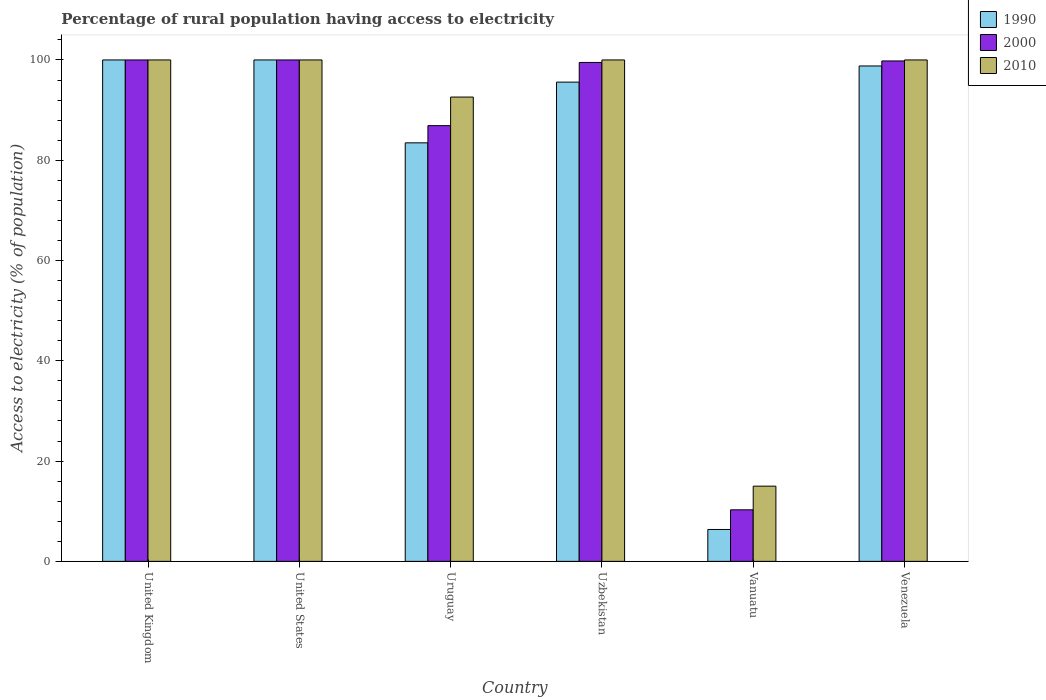How many groups of bars are there?
Ensure brevity in your answer.  6. Are the number of bars on each tick of the X-axis equal?
Offer a terse response. Yes. How many bars are there on the 2nd tick from the left?
Offer a very short reply. 3. What is the label of the 4th group of bars from the left?
Your response must be concise. Uzbekistan. What is the percentage of rural population having access to electricity in 1990 in Vanuatu?
Offer a very short reply. 6.36. Across all countries, what is the minimum percentage of rural population having access to electricity in 2000?
Make the answer very short. 10.28. In which country was the percentage of rural population having access to electricity in 2010 maximum?
Ensure brevity in your answer.  United Kingdom. In which country was the percentage of rural population having access to electricity in 1990 minimum?
Provide a succinct answer. Vanuatu. What is the total percentage of rural population having access to electricity in 2010 in the graph?
Your response must be concise. 507.6. What is the difference between the percentage of rural population having access to electricity in 2000 in Uruguay and that in Uzbekistan?
Keep it short and to the point. -12.6. What is the difference between the percentage of rural population having access to electricity in 1990 in Vanuatu and the percentage of rural population having access to electricity in 2000 in United Kingdom?
Your answer should be very brief. -93.64. What is the average percentage of rural population having access to electricity in 1990 per country?
Offer a very short reply. 80.7. What is the difference between the percentage of rural population having access to electricity of/in 2000 and percentage of rural population having access to electricity of/in 2010 in Venezuela?
Your response must be concise. -0.2. What is the ratio of the percentage of rural population having access to electricity in 2000 in United Kingdom to that in Uzbekistan?
Keep it short and to the point. 1.01. What is the difference between the highest and the second highest percentage of rural population having access to electricity in 2000?
Offer a terse response. -0.2. What is the difference between the highest and the lowest percentage of rural population having access to electricity in 1990?
Provide a short and direct response. 93.64. In how many countries, is the percentage of rural population having access to electricity in 2000 greater than the average percentage of rural population having access to electricity in 2000 taken over all countries?
Give a very brief answer. 5. What does the 3rd bar from the right in Venezuela represents?
Your answer should be very brief. 1990. Is it the case that in every country, the sum of the percentage of rural population having access to electricity in 2000 and percentage of rural population having access to electricity in 2010 is greater than the percentage of rural population having access to electricity in 1990?
Offer a very short reply. Yes. Are all the bars in the graph horizontal?
Ensure brevity in your answer.  No. What is the difference between two consecutive major ticks on the Y-axis?
Your answer should be compact. 20. Are the values on the major ticks of Y-axis written in scientific E-notation?
Provide a succinct answer. No. Does the graph contain any zero values?
Provide a short and direct response. No. How many legend labels are there?
Provide a short and direct response. 3. How are the legend labels stacked?
Offer a terse response. Vertical. What is the title of the graph?
Your answer should be compact. Percentage of rural population having access to electricity. Does "1963" appear as one of the legend labels in the graph?
Keep it short and to the point. No. What is the label or title of the X-axis?
Your answer should be compact. Country. What is the label or title of the Y-axis?
Offer a terse response. Access to electricity (% of population). What is the Access to electricity (% of population) of 1990 in United Kingdom?
Your answer should be compact. 100. What is the Access to electricity (% of population) of 2000 in United Kingdom?
Offer a very short reply. 100. What is the Access to electricity (% of population) in 2010 in United States?
Give a very brief answer. 100. What is the Access to electricity (% of population) in 1990 in Uruguay?
Your answer should be compact. 83.47. What is the Access to electricity (% of population) of 2000 in Uruguay?
Your answer should be compact. 86.9. What is the Access to electricity (% of population) in 2010 in Uruguay?
Give a very brief answer. 92.6. What is the Access to electricity (% of population) in 1990 in Uzbekistan?
Ensure brevity in your answer.  95.58. What is the Access to electricity (% of population) in 2000 in Uzbekistan?
Your answer should be compact. 99.5. What is the Access to electricity (% of population) in 2010 in Uzbekistan?
Make the answer very short. 100. What is the Access to electricity (% of population) in 1990 in Vanuatu?
Provide a short and direct response. 6.36. What is the Access to electricity (% of population) in 2000 in Vanuatu?
Ensure brevity in your answer.  10.28. What is the Access to electricity (% of population) of 2010 in Vanuatu?
Offer a terse response. 15. What is the Access to electricity (% of population) of 1990 in Venezuela?
Give a very brief answer. 98.8. What is the Access to electricity (% of population) in 2000 in Venezuela?
Give a very brief answer. 99.8. What is the Access to electricity (% of population) of 2010 in Venezuela?
Ensure brevity in your answer.  100. Across all countries, what is the maximum Access to electricity (% of population) of 1990?
Ensure brevity in your answer.  100. Across all countries, what is the maximum Access to electricity (% of population) of 2000?
Your answer should be very brief. 100. Across all countries, what is the minimum Access to electricity (% of population) of 1990?
Ensure brevity in your answer.  6.36. Across all countries, what is the minimum Access to electricity (% of population) in 2000?
Give a very brief answer. 10.28. Across all countries, what is the minimum Access to electricity (% of population) of 2010?
Give a very brief answer. 15. What is the total Access to electricity (% of population) of 1990 in the graph?
Offer a terse response. 484.21. What is the total Access to electricity (% of population) of 2000 in the graph?
Provide a short and direct response. 496.48. What is the total Access to electricity (% of population) of 2010 in the graph?
Your answer should be very brief. 507.6. What is the difference between the Access to electricity (% of population) of 1990 in United Kingdom and that in United States?
Your answer should be compact. 0. What is the difference between the Access to electricity (% of population) in 2000 in United Kingdom and that in United States?
Provide a succinct answer. 0. What is the difference between the Access to electricity (% of population) in 2010 in United Kingdom and that in United States?
Offer a very short reply. 0. What is the difference between the Access to electricity (% of population) of 1990 in United Kingdom and that in Uruguay?
Make the answer very short. 16.53. What is the difference between the Access to electricity (% of population) in 1990 in United Kingdom and that in Uzbekistan?
Give a very brief answer. 4.42. What is the difference between the Access to electricity (% of population) in 2010 in United Kingdom and that in Uzbekistan?
Your response must be concise. 0. What is the difference between the Access to electricity (% of population) in 1990 in United Kingdom and that in Vanuatu?
Ensure brevity in your answer.  93.64. What is the difference between the Access to electricity (% of population) in 2000 in United Kingdom and that in Vanuatu?
Provide a short and direct response. 89.72. What is the difference between the Access to electricity (% of population) in 2010 in United Kingdom and that in Vanuatu?
Give a very brief answer. 85. What is the difference between the Access to electricity (% of population) of 1990 in United Kingdom and that in Venezuela?
Ensure brevity in your answer.  1.2. What is the difference between the Access to electricity (% of population) of 2010 in United Kingdom and that in Venezuela?
Offer a very short reply. 0. What is the difference between the Access to electricity (% of population) in 1990 in United States and that in Uruguay?
Offer a very short reply. 16.53. What is the difference between the Access to electricity (% of population) in 1990 in United States and that in Uzbekistan?
Offer a terse response. 4.42. What is the difference between the Access to electricity (% of population) of 2010 in United States and that in Uzbekistan?
Keep it short and to the point. 0. What is the difference between the Access to electricity (% of population) in 1990 in United States and that in Vanuatu?
Your answer should be compact. 93.64. What is the difference between the Access to electricity (% of population) of 2000 in United States and that in Vanuatu?
Your response must be concise. 89.72. What is the difference between the Access to electricity (% of population) in 1990 in United States and that in Venezuela?
Offer a terse response. 1.2. What is the difference between the Access to electricity (% of population) of 2010 in United States and that in Venezuela?
Offer a very short reply. 0. What is the difference between the Access to electricity (% of population) in 1990 in Uruguay and that in Uzbekistan?
Your response must be concise. -12.11. What is the difference between the Access to electricity (% of population) of 2010 in Uruguay and that in Uzbekistan?
Your answer should be very brief. -7.4. What is the difference between the Access to electricity (% of population) of 1990 in Uruguay and that in Vanuatu?
Give a very brief answer. 77.11. What is the difference between the Access to electricity (% of population) of 2000 in Uruguay and that in Vanuatu?
Give a very brief answer. 76.62. What is the difference between the Access to electricity (% of population) in 2010 in Uruguay and that in Vanuatu?
Keep it short and to the point. 77.6. What is the difference between the Access to electricity (% of population) of 1990 in Uruguay and that in Venezuela?
Offer a very short reply. -15.33. What is the difference between the Access to electricity (% of population) of 2000 in Uruguay and that in Venezuela?
Offer a terse response. -12.9. What is the difference between the Access to electricity (% of population) of 1990 in Uzbekistan and that in Vanuatu?
Your answer should be very brief. 89.22. What is the difference between the Access to electricity (% of population) in 2000 in Uzbekistan and that in Vanuatu?
Keep it short and to the point. 89.22. What is the difference between the Access to electricity (% of population) in 2010 in Uzbekistan and that in Vanuatu?
Your answer should be compact. 85. What is the difference between the Access to electricity (% of population) in 1990 in Uzbekistan and that in Venezuela?
Ensure brevity in your answer.  -3.22. What is the difference between the Access to electricity (% of population) in 2010 in Uzbekistan and that in Venezuela?
Offer a terse response. 0. What is the difference between the Access to electricity (% of population) of 1990 in Vanuatu and that in Venezuela?
Your answer should be compact. -92.44. What is the difference between the Access to electricity (% of population) of 2000 in Vanuatu and that in Venezuela?
Offer a terse response. -89.52. What is the difference between the Access to electricity (% of population) in 2010 in Vanuatu and that in Venezuela?
Your response must be concise. -85. What is the difference between the Access to electricity (% of population) of 1990 in United Kingdom and the Access to electricity (% of population) of 2010 in Uruguay?
Provide a short and direct response. 7.4. What is the difference between the Access to electricity (% of population) of 2000 in United Kingdom and the Access to electricity (% of population) of 2010 in Uruguay?
Your response must be concise. 7.4. What is the difference between the Access to electricity (% of population) in 1990 in United Kingdom and the Access to electricity (% of population) in 2000 in Vanuatu?
Give a very brief answer. 89.72. What is the difference between the Access to electricity (% of population) of 1990 in United Kingdom and the Access to electricity (% of population) of 2010 in Vanuatu?
Your response must be concise. 85. What is the difference between the Access to electricity (% of population) of 2000 in United Kingdom and the Access to electricity (% of population) of 2010 in Vanuatu?
Provide a succinct answer. 85. What is the difference between the Access to electricity (% of population) in 1990 in United Kingdom and the Access to electricity (% of population) in 2000 in Venezuela?
Keep it short and to the point. 0.2. What is the difference between the Access to electricity (% of population) in 1990 in United States and the Access to electricity (% of population) in 2010 in Uruguay?
Your answer should be very brief. 7.4. What is the difference between the Access to electricity (% of population) in 2000 in United States and the Access to electricity (% of population) in 2010 in Uzbekistan?
Offer a terse response. 0. What is the difference between the Access to electricity (% of population) in 1990 in United States and the Access to electricity (% of population) in 2000 in Vanuatu?
Provide a short and direct response. 89.72. What is the difference between the Access to electricity (% of population) in 1990 in United States and the Access to electricity (% of population) in 2000 in Venezuela?
Provide a succinct answer. 0.2. What is the difference between the Access to electricity (% of population) in 1990 in Uruguay and the Access to electricity (% of population) in 2000 in Uzbekistan?
Your answer should be very brief. -16.03. What is the difference between the Access to electricity (% of population) in 1990 in Uruguay and the Access to electricity (% of population) in 2010 in Uzbekistan?
Offer a terse response. -16.53. What is the difference between the Access to electricity (% of population) in 2000 in Uruguay and the Access to electricity (% of population) in 2010 in Uzbekistan?
Your answer should be very brief. -13.1. What is the difference between the Access to electricity (% of population) of 1990 in Uruguay and the Access to electricity (% of population) of 2000 in Vanuatu?
Offer a very short reply. 73.19. What is the difference between the Access to electricity (% of population) in 1990 in Uruguay and the Access to electricity (% of population) in 2010 in Vanuatu?
Give a very brief answer. 68.47. What is the difference between the Access to electricity (% of population) in 2000 in Uruguay and the Access to electricity (% of population) in 2010 in Vanuatu?
Offer a very short reply. 71.9. What is the difference between the Access to electricity (% of population) of 1990 in Uruguay and the Access to electricity (% of population) of 2000 in Venezuela?
Make the answer very short. -16.33. What is the difference between the Access to electricity (% of population) of 1990 in Uruguay and the Access to electricity (% of population) of 2010 in Venezuela?
Provide a short and direct response. -16.53. What is the difference between the Access to electricity (% of population) of 2000 in Uruguay and the Access to electricity (% of population) of 2010 in Venezuela?
Offer a very short reply. -13.1. What is the difference between the Access to electricity (% of population) of 1990 in Uzbekistan and the Access to electricity (% of population) of 2000 in Vanuatu?
Your answer should be compact. 85.3. What is the difference between the Access to electricity (% of population) in 1990 in Uzbekistan and the Access to electricity (% of population) in 2010 in Vanuatu?
Provide a short and direct response. 80.58. What is the difference between the Access to electricity (% of population) in 2000 in Uzbekistan and the Access to electricity (% of population) in 2010 in Vanuatu?
Your response must be concise. 84.5. What is the difference between the Access to electricity (% of population) of 1990 in Uzbekistan and the Access to electricity (% of population) of 2000 in Venezuela?
Give a very brief answer. -4.22. What is the difference between the Access to electricity (% of population) of 1990 in Uzbekistan and the Access to electricity (% of population) of 2010 in Venezuela?
Provide a short and direct response. -4.42. What is the difference between the Access to electricity (% of population) of 1990 in Vanuatu and the Access to electricity (% of population) of 2000 in Venezuela?
Provide a short and direct response. -93.44. What is the difference between the Access to electricity (% of population) of 1990 in Vanuatu and the Access to electricity (% of population) of 2010 in Venezuela?
Offer a terse response. -93.64. What is the difference between the Access to electricity (% of population) in 2000 in Vanuatu and the Access to electricity (% of population) in 2010 in Venezuela?
Make the answer very short. -89.72. What is the average Access to electricity (% of population) of 1990 per country?
Your answer should be compact. 80.7. What is the average Access to electricity (% of population) of 2000 per country?
Provide a succinct answer. 82.75. What is the average Access to electricity (% of population) of 2010 per country?
Your response must be concise. 84.6. What is the difference between the Access to electricity (% of population) of 1990 and Access to electricity (% of population) of 2000 in Uruguay?
Make the answer very short. -3.43. What is the difference between the Access to electricity (% of population) in 1990 and Access to electricity (% of population) in 2010 in Uruguay?
Keep it short and to the point. -9.13. What is the difference between the Access to electricity (% of population) of 2000 and Access to electricity (% of population) of 2010 in Uruguay?
Your answer should be very brief. -5.7. What is the difference between the Access to electricity (% of population) in 1990 and Access to electricity (% of population) in 2000 in Uzbekistan?
Provide a short and direct response. -3.92. What is the difference between the Access to electricity (% of population) of 1990 and Access to electricity (% of population) of 2010 in Uzbekistan?
Give a very brief answer. -4.42. What is the difference between the Access to electricity (% of population) of 2000 and Access to electricity (% of population) of 2010 in Uzbekistan?
Ensure brevity in your answer.  -0.5. What is the difference between the Access to electricity (% of population) in 1990 and Access to electricity (% of population) in 2000 in Vanuatu?
Ensure brevity in your answer.  -3.92. What is the difference between the Access to electricity (% of population) of 1990 and Access to electricity (% of population) of 2010 in Vanuatu?
Your answer should be very brief. -8.64. What is the difference between the Access to electricity (% of population) in 2000 and Access to electricity (% of population) in 2010 in Vanuatu?
Provide a short and direct response. -4.72. What is the difference between the Access to electricity (% of population) in 1990 and Access to electricity (% of population) in 2010 in Venezuela?
Make the answer very short. -1.2. What is the difference between the Access to electricity (% of population) of 2000 and Access to electricity (% of population) of 2010 in Venezuela?
Make the answer very short. -0.2. What is the ratio of the Access to electricity (% of population) in 1990 in United Kingdom to that in United States?
Your response must be concise. 1. What is the ratio of the Access to electricity (% of population) of 2010 in United Kingdom to that in United States?
Your answer should be compact. 1. What is the ratio of the Access to electricity (% of population) in 1990 in United Kingdom to that in Uruguay?
Your response must be concise. 1.2. What is the ratio of the Access to electricity (% of population) of 2000 in United Kingdom to that in Uruguay?
Ensure brevity in your answer.  1.15. What is the ratio of the Access to electricity (% of population) in 2010 in United Kingdom to that in Uruguay?
Provide a short and direct response. 1.08. What is the ratio of the Access to electricity (% of population) of 1990 in United Kingdom to that in Uzbekistan?
Provide a short and direct response. 1.05. What is the ratio of the Access to electricity (% of population) of 2000 in United Kingdom to that in Uzbekistan?
Your answer should be compact. 1. What is the ratio of the Access to electricity (% of population) in 1990 in United Kingdom to that in Vanuatu?
Offer a very short reply. 15.72. What is the ratio of the Access to electricity (% of population) in 2000 in United Kingdom to that in Vanuatu?
Provide a succinct answer. 9.73. What is the ratio of the Access to electricity (% of population) of 1990 in United Kingdom to that in Venezuela?
Provide a short and direct response. 1.01. What is the ratio of the Access to electricity (% of population) of 2010 in United Kingdom to that in Venezuela?
Ensure brevity in your answer.  1. What is the ratio of the Access to electricity (% of population) in 1990 in United States to that in Uruguay?
Offer a terse response. 1.2. What is the ratio of the Access to electricity (% of population) of 2000 in United States to that in Uruguay?
Make the answer very short. 1.15. What is the ratio of the Access to electricity (% of population) in 2010 in United States to that in Uruguay?
Make the answer very short. 1.08. What is the ratio of the Access to electricity (% of population) in 1990 in United States to that in Uzbekistan?
Provide a succinct answer. 1.05. What is the ratio of the Access to electricity (% of population) of 1990 in United States to that in Vanuatu?
Your answer should be very brief. 15.72. What is the ratio of the Access to electricity (% of population) of 2000 in United States to that in Vanuatu?
Your answer should be very brief. 9.73. What is the ratio of the Access to electricity (% of population) of 2010 in United States to that in Vanuatu?
Offer a terse response. 6.67. What is the ratio of the Access to electricity (% of population) in 1990 in United States to that in Venezuela?
Your answer should be compact. 1.01. What is the ratio of the Access to electricity (% of population) in 2000 in United States to that in Venezuela?
Provide a succinct answer. 1. What is the ratio of the Access to electricity (% of population) of 1990 in Uruguay to that in Uzbekistan?
Offer a terse response. 0.87. What is the ratio of the Access to electricity (% of population) of 2000 in Uruguay to that in Uzbekistan?
Make the answer very short. 0.87. What is the ratio of the Access to electricity (% of population) in 2010 in Uruguay to that in Uzbekistan?
Make the answer very short. 0.93. What is the ratio of the Access to electricity (% of population) in 1990 in Uruguay to that in Vanuatu?
Keep it short and to the point. 13.12. What is the ratio of the Access to electricity (% of population) in 2000 in Uruguay to that in Vanuatu?
Offer a terse response. 8.45. What is the ratio of the Access to electricity (% of population) in 2010 in Uruguay to that in Vanuatu?
Offer a terse response. 6.17. What is the ratio of the Access to electricity (% of population) in 1990 in Uruguay to that in Venezuela?
Your answer should be very brief. 0.84. What is the ratio of the Access to electricity (% of population) of 2000 in Uruguay to that in Venezuela?
Give a very brief answer. 0.87. What is the ratio of the Access to electricity (% of population) of 2010 in Uruguay to that in Venezuela?
Ensure brevity in your answer.  0.93. What is the ratio of the Access to electricity (% of population) of 1990 in Uzbekistan to that in Vanuatu?
Give a very brief answer. 15.03. What is the ratio of the Access to electricity (% of population) of 2000 in Uzbekistan to that in Vanuatu?
Your response must be concise. 9.68. What is the ratio of the Access to electricity (% of population) of 2010 in Uzbekistan to that in Vanuatu?
Offer a very short reply. 6.67. What is the ratio of the Access to electricity (% of population) in 1990 in Uzbekistan to that in Venezuela?
Your answer should be compact. 0.97. What is the ratio of the Access to electricity (% of population) of 1990 in Vanuatu to that in Venezuela?
Keep it short and to the point. 0.06. What is the ratio of the Access to electricity (% of population) in 2000 in Vanuatu to that in Venezuela?
Provide a short and direct response. 0.1. What is the ratio of the Access to electricity (% of population) of 2010 in Vanuatu to that in Venezuela?
Your answer should be compact. 0.15. What is the difference between the highest and the second highest Access to electricity (% of population) in 2010?
Offer a very short reply. 0. What is the difference between the highest and the lowest Access to electricity (% of population) of 1990?
Provide a succinct answer. 93.64. What is the difference between the highest and the lowest Access to electricity (% of population) in 2000?
Your response must be concise. 89.72. 